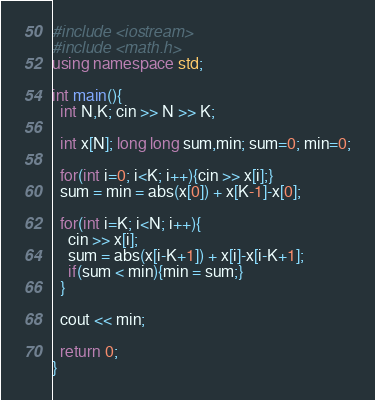Convert code to text. <code><loc_0><loc_0><loc_500><loc_500><_C++_>#include <iostream>
#include <math.h>
using namespace std;

int main(){
  int N,K; cin >> N >> K;
  
  int x[N]; long long sum,min; sum=0; min=0;
  
  for(int i=0; i<K; i++){cin >> x[i];}
  sum = min = abs(x[0]) + x[K-1]-x[0];
  
  for(int i=K; i<N; i++){
    cin >> x[i];
    sum = abs(x[i-K+1]) + x[i]-x[i-K+1];
    if(sum < min){min = sum;}
  }
  
  cout << min;
  
  return 0;
}</code> 